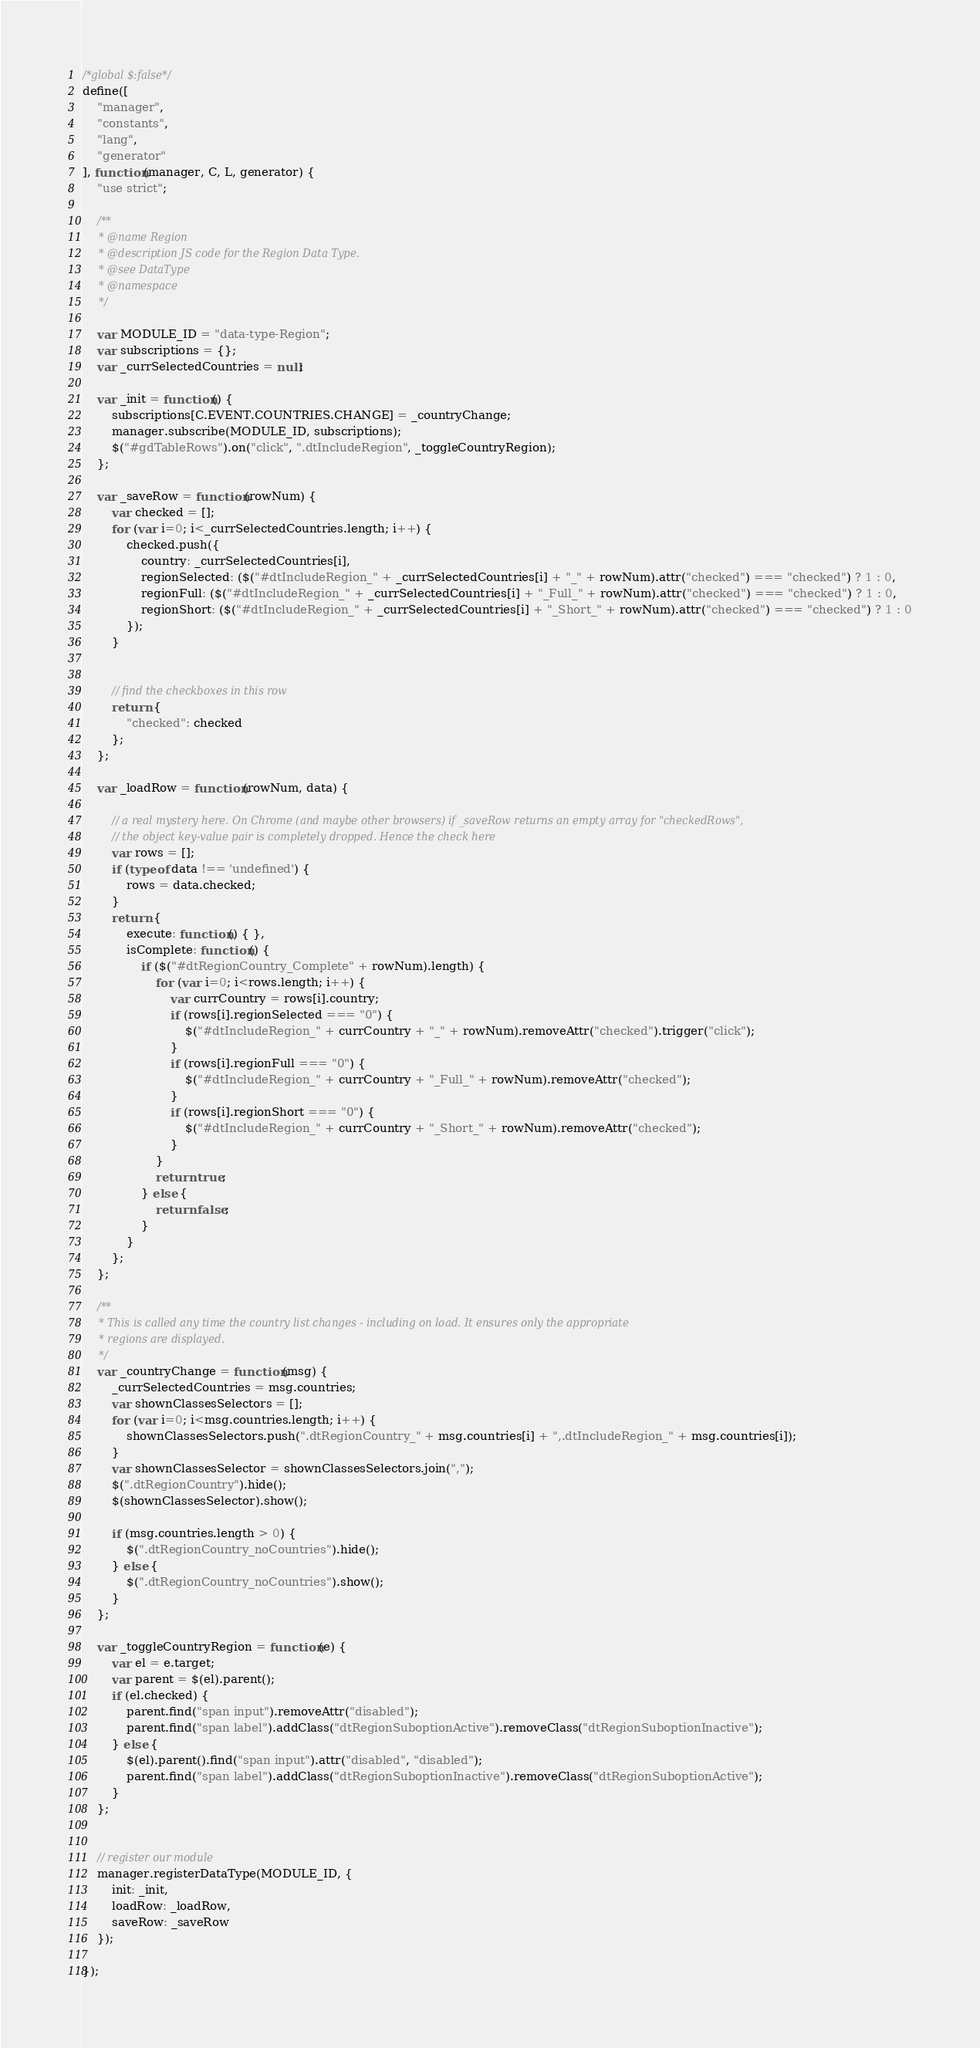<code> <loc_0><loc_0><loc_500><loc_500><_JavaScript_>/*global $:false*/
define([
	"manager",
	"constants",
	"lang",
	"generator"
], function(manager, C, L, generator) {
	"use strict";

	/**
	 * @name Region
	 * @description JS code for the Region Data Type.
	 * @see DataType
	 * @namespace
	 */

	var MODULE_ID = "data-type-Region";
	var subscriptions = {};
	var _currSelectedCountries = null;

	var _init = function() {
		subscriptions[C.EVENT.COUNTRIES.CHANGE] = _countryChange;
		manager.subscribe(MODULE_ID, subscriptions);
		$("#gdTableRows").on("click", ".dtIncludeRegion", _toggleCountryRegion);
	};

	var _saveRow = function(rowNum) {
		var checked = [];
		for (var i=0; i<_currSelectedCountries.length; i++) {
			checked.push({
				country: _currSelectedCountries[i],
				regionSelected: ($("#dtIncludeRegion_" + _currSelectedCountries[i] + "_" + rowNum).attr("checked") === "checked") ? 1 : 0,
				regionFull: ($("#dtIncludeRegion_" + _currSelectedCountries[i] + "_Full_" + rowNum).attr("checked") === "checked") ? 1 : 0,
				regionShort: ($("#dtIncludeRegion_" + _currSelectedCountries[i] + "_Short_" + rowNum).attr("checked") === "checked") ? 1 : 0
			});
		}


		// find the checkboxes in this row
		return {
			"checked": checked
		};
	};

	var _loadRow = function(rowNum, data) {

		// a real mystery here. On Chrome (and maybe other browsers) if _saveRow returns an empty array for "checkedRows",
		// the object key-value pair is completely dropped. Hence the check here
		var rows = [];
		if (typeof data !== 'undefined') {
			rows = data.checked;
		}
		return {
			execute: function() { },
			isComplete: function() {
				if ($("#dtRegionCountry_Complete" + rowNum).length) {
					for (var i=0; i<rows.length; i++) {
						var currCountry = rows[i].country;
						if (rows[i].regionSelected === "0") {
							$("#dtIncludeRegion_" + currCountry + "_" + rowNum).removeAttr("checked").trigger("click");
						}
						if (rows[i].regionFull === "0") {
							$("#dtIncludeRegion_" + currCountry + "_Full_" + rowNum).removeAttr("checked");
						}
						if (rows[i].regionShort === "0") {
							$("#dtIncludeRegion_" + currCountry + "_Short_" + rowNum).removeAttr("checked");
						}
					}
					return true;
				} else {
					return false;
				}
			}
		};
	};

	/**
	 * This is called any time the country list changes - including on load. It ensures only the appropriate
	 * regions are displayed.
	 */
	var _countryChange = function(msg) {
		_currSelectedCountries = msg.countries;
		var shownClassesSelectors = [];
		for (var i=0; i<msg.countries.length; i++) {
			shownClassesSelectors.push(".dtRegionCountry_" + msg.countries[i] + ",.dtIncludeRegion_" + msg.countries[i]);
		}
		var shownClassesSelector = shownClassesSelectors.join(",");
		$(".dtRegionCountry").hide();
		$(shownClassesSelector).show();

		if (msg.countries.length > 0) {
			$(".dtRegionCountry_noCountries").hide();
		} else {
			$(".dtRegionCountry_noCountries").show();
		}
	};

	var _toggleCountryRegion = function(e) {
		var el = e.target;
		var parent = $(el).parent();
		if (el.checked) {
			parent.find("span input").removeAttr("disabled");
			parent.find("span label").addClass("dtRegionSuboptionActive").removeClass("dtRegionSuboptionInactive");
		} else {
			$(el).parent().find("span input").attr("disabled", "disabled");
			parent.find("span label").addClass("dtRegionSuboptionInactive").removeClass("dtRegionSuboptionActive");
		}
	};


	// register our module
	manager.registerDataType(MODULE_ID, {
		init: _init,
		loadRow: _loadRow,
		saveRow: _saveRow
	});

});
</code> 